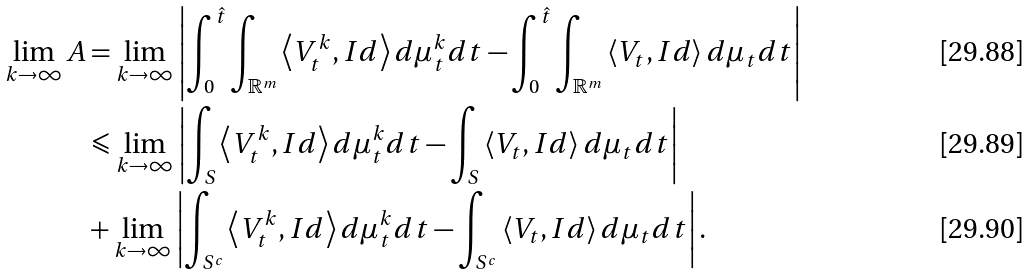Convert formula to latex. <formula><loc_0><loc_0><loc_500><loc_500>\lim _ { k \to \infty } A & = \lim _ { k \to \infty } \left | \int _ { 0 } ^ { \hat { t } } \int _ { \mathbb { R } ^ { m } } \left \langle V _ { t } ^ { k } , I d \right \rangle d \mu _ { t } ^ { k } d t - \int _ { 0 } ^ { \hat { t } } \int _ { \mathbb { R } ^ { m } } \left \langle V _ { t } , I d \right \rangle d \mu _ { t } d t \right | \\ & \leqslant \lim _ { k \to \infty } \left | \int _ { S } \left \langle V _ { t } ^ { k } , I d \right \rangle d \mu _ { t } ^ { k } d t - \int _ { S } \left \langle V _ { t } , I d \right \rangle d \mu _ { t } d t \right | \\ & + \lim _ { k \to \infty } \left | \int _ { S ^ { c } } \left \langle V _ { t } ^ { k } , I d \right \rangle d \mu _ { t } ^ { k } d t - \int _ { S ^ { c } } \left \langle V _ { t } , I d \right \rangle d \mu _ { t } d t \right | .</formula> 